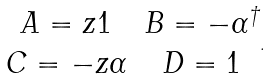<formula> <loc_0><loc_0><loc_500><loc_500>\begin{matrix} A = z 1 & B = - \alpha ^ { \dagger } \\ C = - z \alpha & D = 1 \end{matrix} .</formula> 